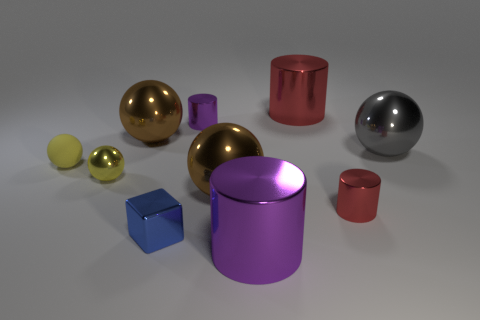Subtract all small yellow matte balls. How many balls are left? 4 Subtract 1 balls. How many balls are left? 4 Subtract all brown balls. How many balls are left? 3 Subtract all cubes. How many objects are left? 9 Subtract all cyan cylinders. Subtract all brown balls. How many cylinders are left? 4 Subtract all purple cubes. How many brown cylinders are left? 0 Subtract all big cylinders. Subtract all tiny yellow balls. How many objects are left? 6 Add 7 gray spheres. How many gray spheres are left? 8 Add 3 small purple metallic cylinders. How many small purple metallic cylinders exist? 4 Subtract 2 purple cylinders. How many objects are left? 8 